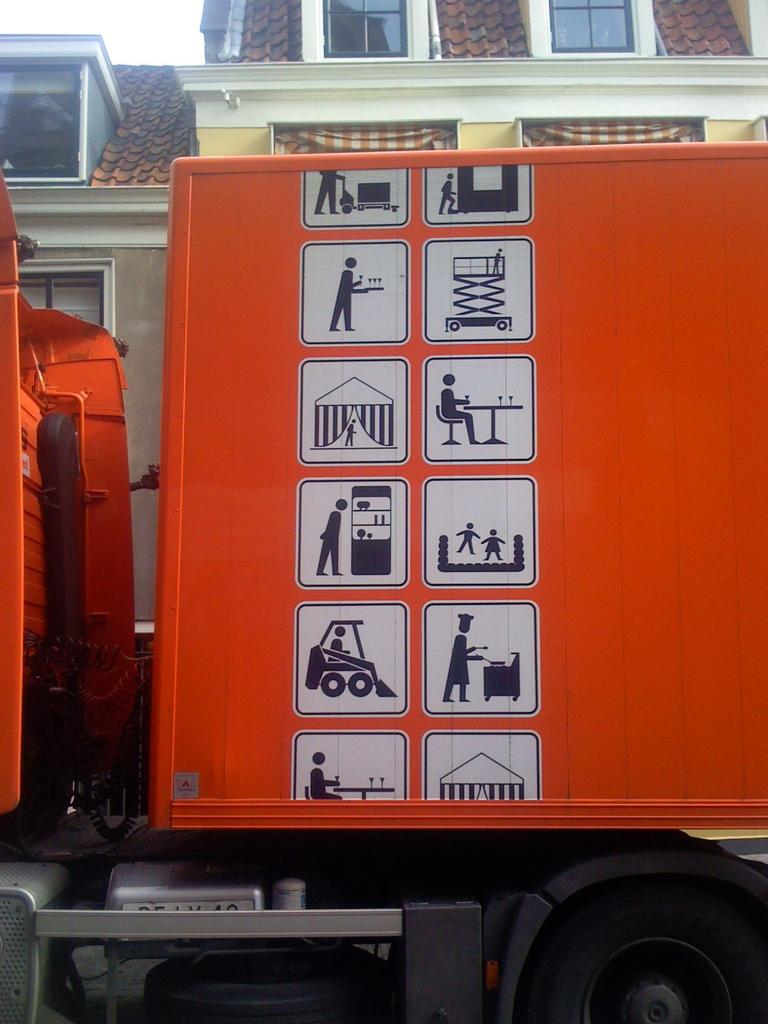What type of vehicle is in the image? There is an orange color vehicle in the image. What can be seen on the vehicle? The vehicle has paintings on it. What can be seen in the background of the image? There are buildings in the background of the image. What feature do the buildings have? The buildings have windows. What is visible in the sky in the background of the image? The sky is visible in the background of the image. What type of leather material can be seen on the ducks in the image? There are no ducks present in the image, and therefore no leather material can be observed. 